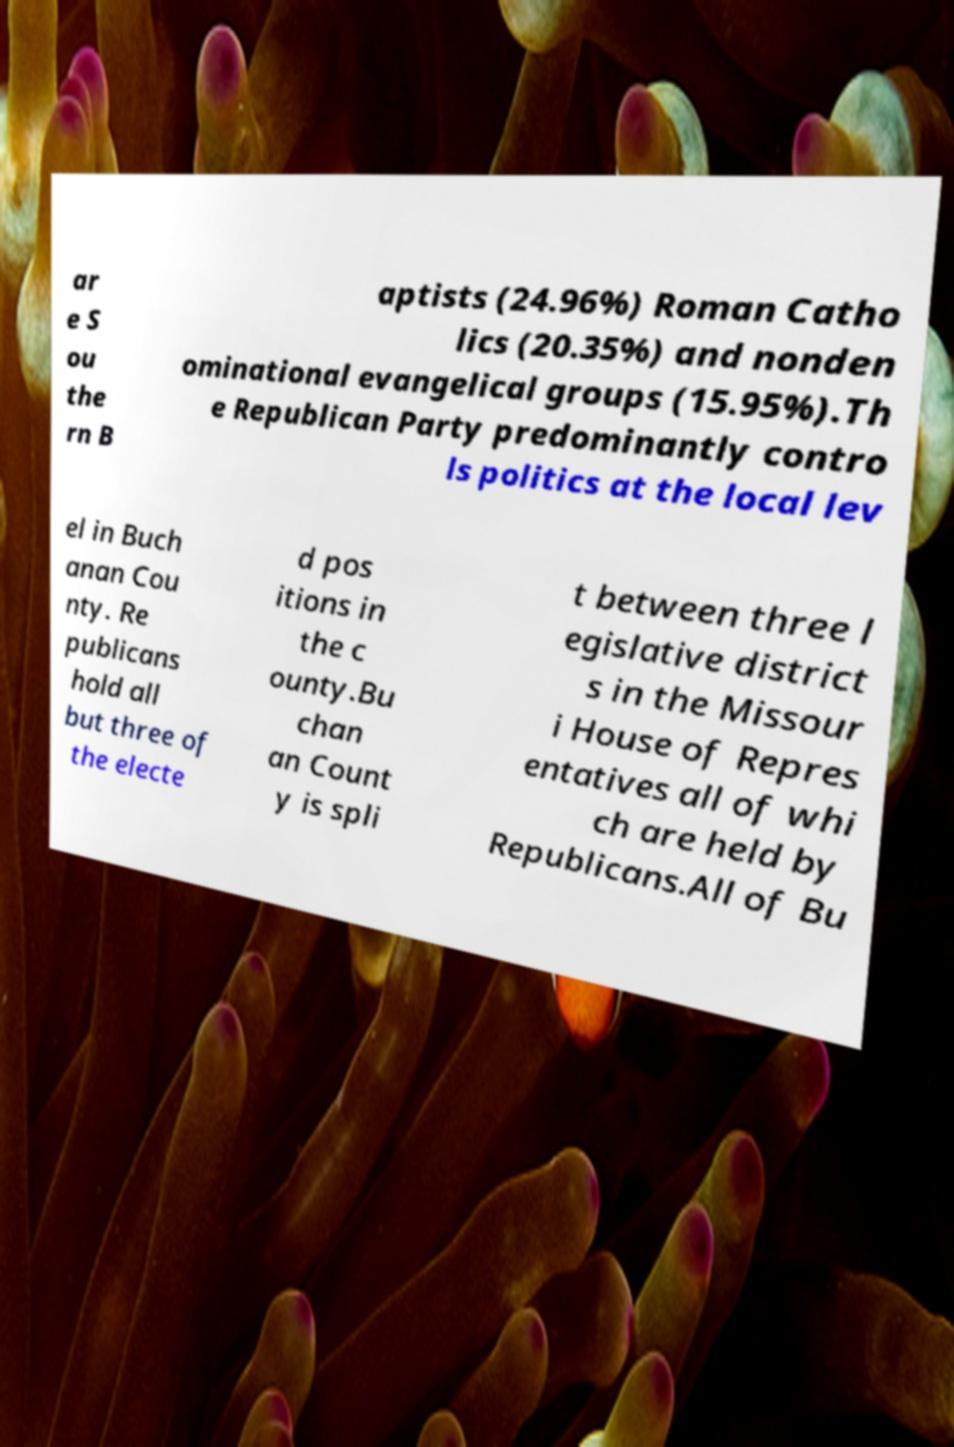There's text embedded in this image that I need extracted. Can you transcribe it verbatim? ar e S ou the rn B aptists (24.96%) Roman Catho lics (20.35%) and nonden ominational evangelical groups (15.95%).Th e Republican Party predominantly contro ls politics at the local lev el in Buch anan Cou nty. Re publicans hold all but three of the electe d pos itions in the c ounty.Bu chan an Count y is spli t between three l egislative district s in the Missour i House of Repres entatives all of whi ch are held by Republicans.All of Bu 